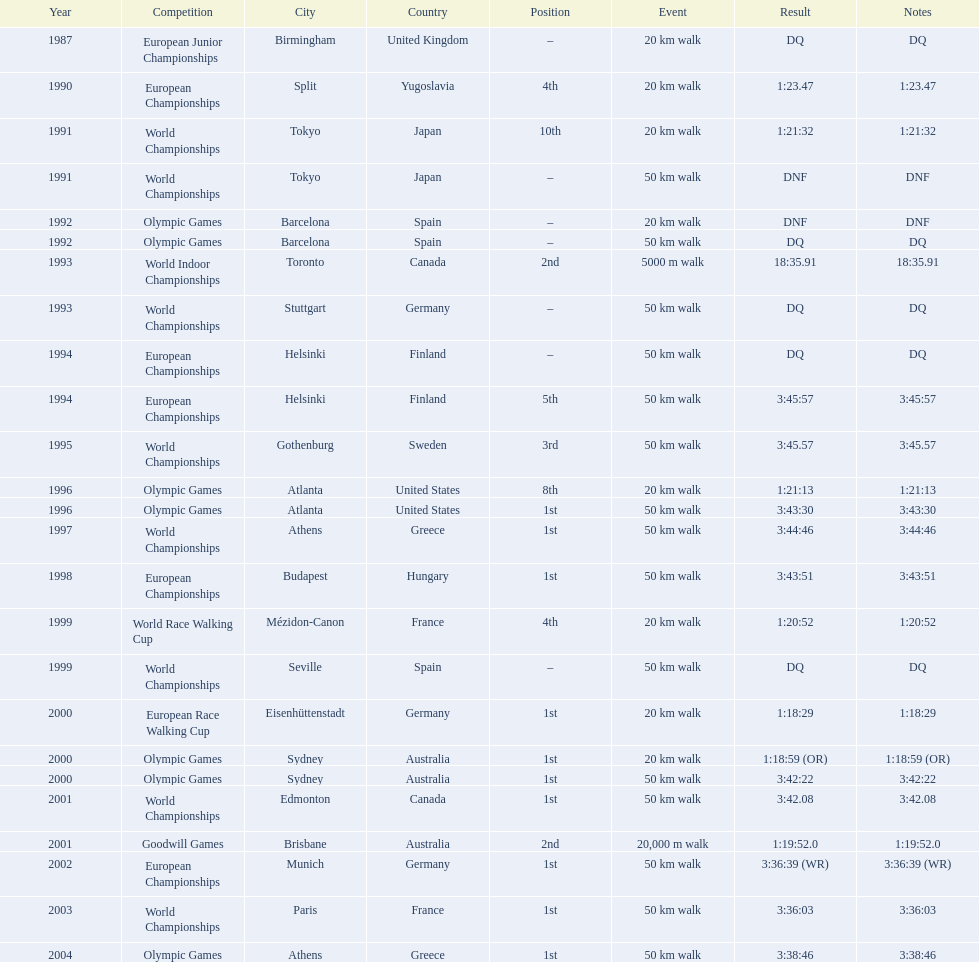What was the difference between korzeniowski's performance at the 1996 olympic games and the 2000 olympic games in the 20 km walk? 2:14. 